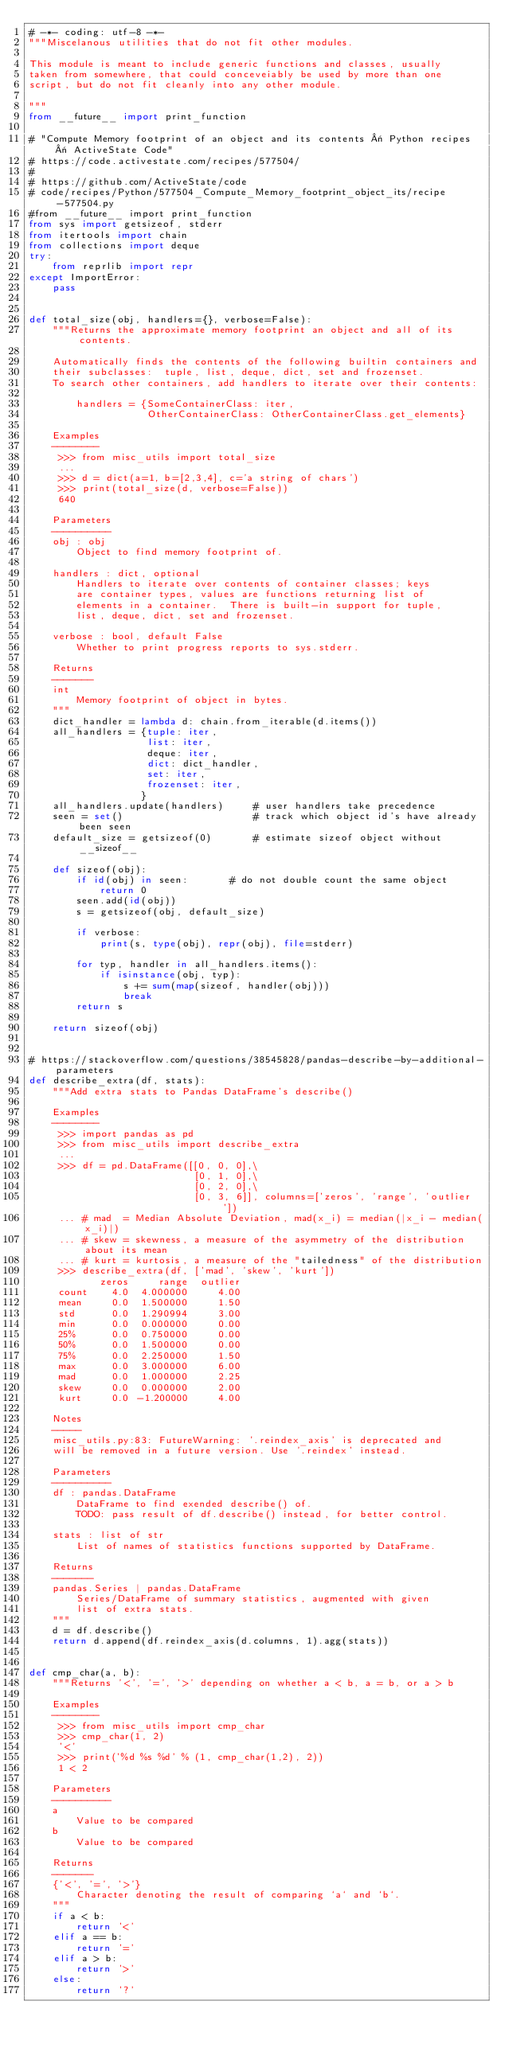<code> <loc_0><loc_0><loc_500><loc_500><_Python_># -*- coding: utf-8 -*-
"""Miscelanous utilities that do not fit other modules.

This module is meant to include generic functions and classes, usually
taken from somewhere, that could conceveiably be used by more than one
script, but do not fit cleanly into any other module.

"""
from __future__ import print_function

# "Compute Memory footprint of an object and its contents « Python recipes « ActiveState Code"
# https://code.activestate.com/recipes/577504/
#
# https://github.com/ActiveState/code
# code/recipes/Python/577504_Compute_Memory_footprint_object_its/recipe-577504.py
#from __future__ import print_function
from sys import getsizeof, stderr
from itertools import chain
from collections import deque
try:
    from reprlib import repr
except ImportError:
    pass


def total_size(obj, handlers={}, verbose=False):
    """Returns the approximate memory footprint an object and all of its contents.

    Automatically finds the contents of the following builtin containers and
    their subclasses:  tuple, list, deque, dict, set and frozenset.
    To search other containers, add handlers to iterate over their contents:

        handlers = {SomeContainerClass: iter,
                    OtherContainerClass: OtherContainerClass.get_elements}

    Examples
    --------
     >>> from misc_utils import total_size
     ...
     >>> d = dict(a=1, b=[2,3,4], c='a string of chars')
     >>> print(total_size(d, verbose=False))
     640

    Parameters
    ----------
    obj : obj
        Object to find memory footprint of.

    handlers : dict, optional
        Handlers to iterate over contents of container classes; keys
        are container types, values are functions returning list of
        elements in a container.  There is built-in support for tuple,
        list, deque, dict, set and frozenset.

    verbose : bool, default False
        Whether to print progress reports to sys.stderr.

    Returns
    -------
    int
        Memory footprint of object in bytes.
    """
    dict_handler = lambda d: chain.from_iterable(d.items())
    all_handlers = {tuple: iter,
                    list: iter,
                    deque: iter,
                    dict: dict_handler,
                    set: iter,
                    frozenset: iter,
                   }
    all_handlers.update(handlers)     # user handlers take precedence
    seen = set()                      # track which object id's have already been seen
    default_size = getsizeof(0)       # estimate sizeof object without __sizeof__

    def sizeof(obj):
        if id(obj) in seen:       # do not double count the same object
            return 0
        seen.add(id(obj))
        s = getsizeof(obj, default_size)

        if verbose:
            print(s, type(obj), repr(obj), file=stderr)

        for typ, handler in all_handlers.items():
            if isinstance(obj, typ):
                s += sum(map(sizeof, handler(obj)))
                break
        return s

    return sizeof(obj)


# https://stackoverflow.com/questions/38545828/pandas-describe-by-additional-parameters
def describe_extra(df, stats):
    """Add extra stats to Pandas DataFrame's describe()

    Examples
    --------
     >>> import pandas as pd
     >>> from misc_utils import describe_extra
     ...
     >>> df = pd.DataFrame([[0, 0, 0],\
                            [0, 1, 0],\
                            [0, 2, 0],\
                            [0, 3, 6]], columns=['zeros', 'range', 'outlier'])
     ... # mad  = Median Absolute Deviation, mad(x_i) = median(|x_i - median(x_i)|)
     ... # skew = skewness, a measure of the asymmetry of the distribution about its mean
     ... # kurt = kurtosis, a measure of the "tailedness" of the distribution
     >>> describe_extra(df, ['mad', 'skew', 'kurt'])
            zeros     range  outlier
     count    4.0  4.000000     4.00
     mean     0.0  1.500000     1.50
     std      0.0  1.290994     3.00
     min      0.0  0.000000     0.00
     25%      0.0  0.750000     0.00
     50%      0.0  1.500000     0.00
     75%      0.0  2.250000     1.50
     max      0.0  3.000000     6.00
     mad      0.0  1.000000     2.25
     skew     0.0  0.000000     2.00
     kurt     0.0 -1.200000     4.00

    Notes
    -----
    misc_utils.py:83: FutureWarning: '.reindex_axis' is deprecated and
    will be removed in a future version. Use '.reindex' instead.

    Parameters
    ----------
    df : pandas.DataFrame
        DataFrame to find exended describe() of.
        TODO: pass result of df.describe() instead, for better control.

    stats : list of str
        List of names of statistics functions supported by DataFrame.

    Returns
    -------
    pandas.Series | pandas.DataFrame
        Series/DataFrame of summary statistics, augmented with given
        list of extra stats.
    """
    d = df.describe()
    return d.append(df.reindex_axis(d.columns, 1).agg(stats))


def cmp_char(a, b):
    """Returns '<', '=', '>' depending on whether a < b, a = b, or a > b

    Examples
    --------
     >>> from misc_utils import cmp_char
     >>> cmp_char(1, 2)
     '<'
     >>> print('%d %s %d' % (1, cmp_char(1,2), 2))
     1 < 2

    Parameters
    ----------
    a
        Value to be compared
    b
        Value to be compared

    Returns
    -------
    {'<', '=', '>'}
        Character denoting the result of comparing `a` and `b`.
    """
    if a < b:
        return '<'
    elif a == b:
        return '='
    elif a > b:
        return '>'
    else:
        return '?'
</code> 